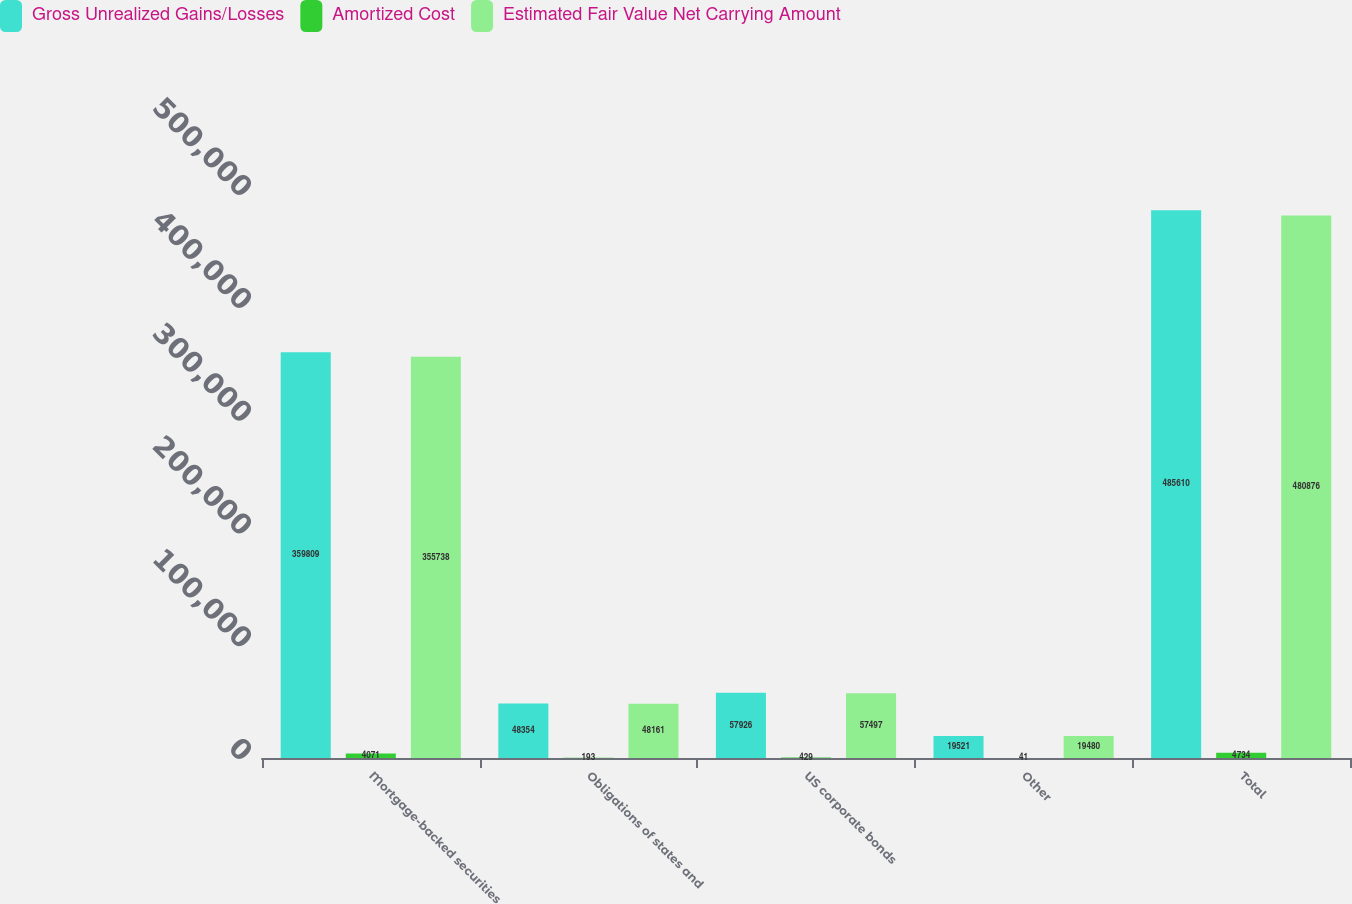Convert chart. <chart><loc_0><loc_0><loc_500><loc_500><stacked_bar_chart><ecel><fcel>Mortgage-backed securities<fcel>Obligations of states and<fcel>US corporate bonds<fcel>Other<fcel>Total<nl><fcel>Gross Unrealized Gains/Losses<fcel>359809<fcel>48354<fcel>57926<fcel>19521<fcel>485610<nl><fcel>Amortized Cost<fcel>4071<fcel>193<fcel>429<fcel>41<fcel>4734<nl><fcel>Estimated Fair Value Net Carrying Amount<fcel>355738<fcel>48161<fcel>57497<fcel>19480<fcel>480876<nl></chart> 